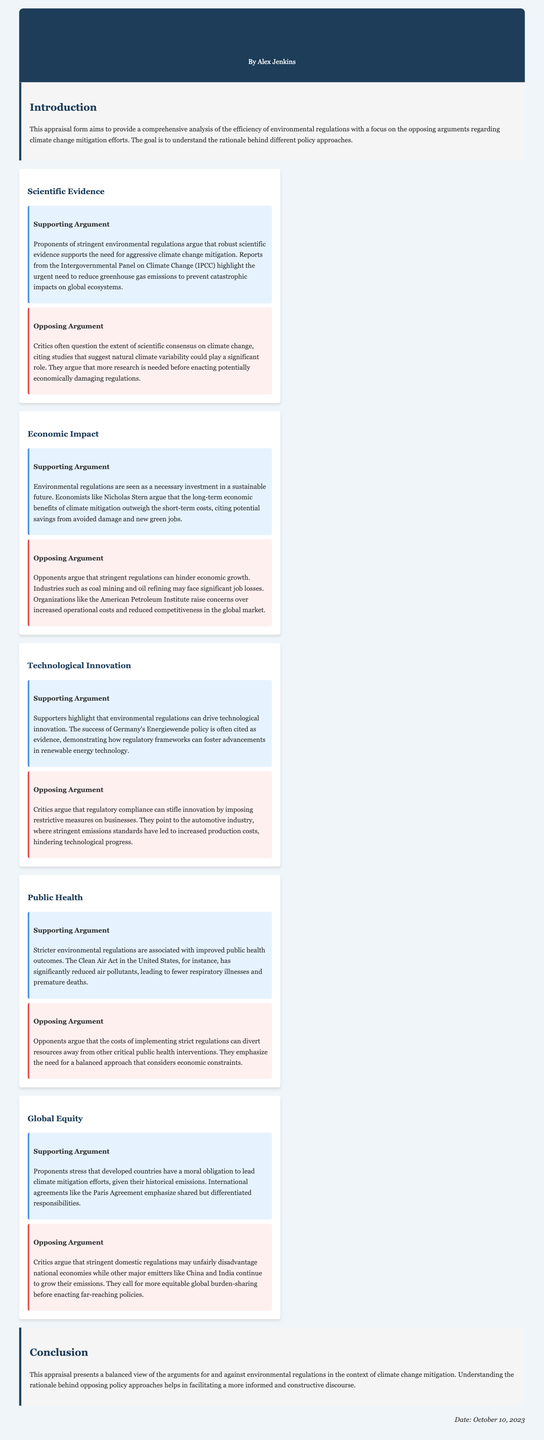What is the title of the document? The title of the document is located at the top of the rendered page, under the header section.
Answer: Environmental Regulation Efficiency Assessment Who authored the appraisal form? The author's name is presented in the header section of the document.
Answer: Alex Jenkins What is the main purpose of this appraisal form? The purpose is indicated in the introduction section of the document.
Answer: To provide a comprehensive analysis of the efficiency of environmental regulations What does the supporting argument under "Scientific Evidence" emphasize? The supporting argument highlights the urgent need for greenhouse gas emissions reduction based on evidence from the IPCC.
Answer: Robust scientific evidence What is one concern raised by critics regarding economic impact? The document states that critics worry about job losses in specific industries due to stringent regulations.
Answer: Job losses What example is provided to support the argument for technological innovation? The document cites Germany's Energiewende policy as an example of fostering advancements in renewable energy technology.
Answer: Energiewende policy What does the opposing argument for public health focus on? The opposing argument emphasizes that strict regulations may divert resources from other health interventions.
Answer: Economic constraints According to the supporting argument on global equity, what obligation do developed countries have? The supporting argument stresses developing countries' moral obligation regarding historical emissions reduction.
Answer: Moral obligation What date was this appraisal form published? The publication date is mentioned at the bottom of the document.
Answer: October 10, 2023 